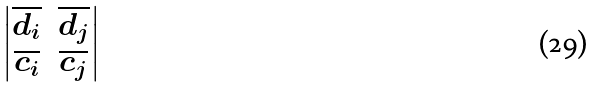<formula> <loc_0><loc_0><loc_500><loc_500>\begin{vmatrix} \overline { d _ { i } } & \overline { d _ { j } } \\ \overline { c _ { i } } & \overline { c _ { j } } \end{vmatrix}</formula> 